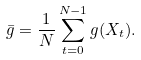Convert formula to latex. <formula><loc_0><loc_0><loc_500><loc_500>\bar { g } = \frac { 1 } { N } \sum _ { t = 0 } ^ { N - 1 } g ( X _ { t } ) .</formula> 